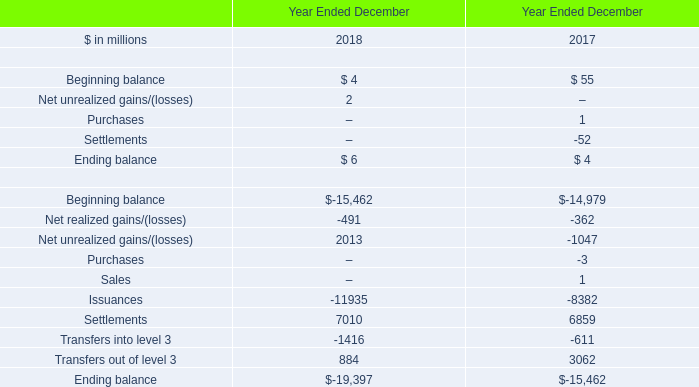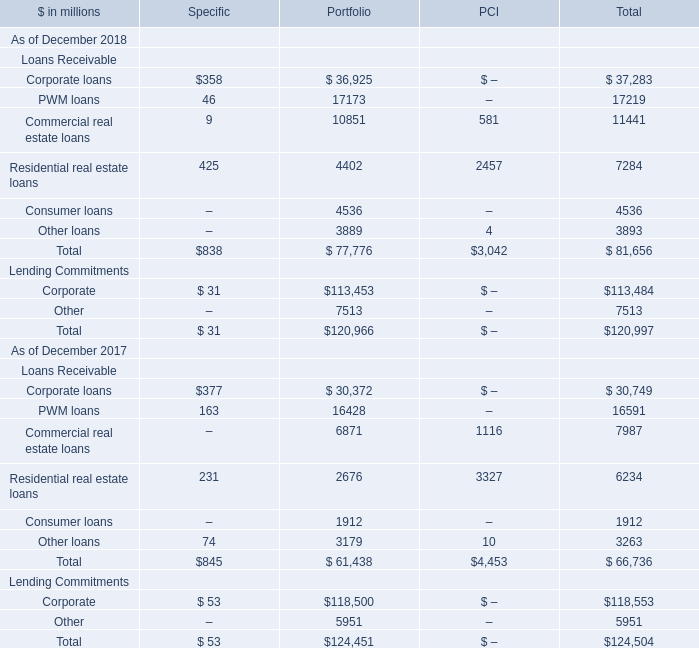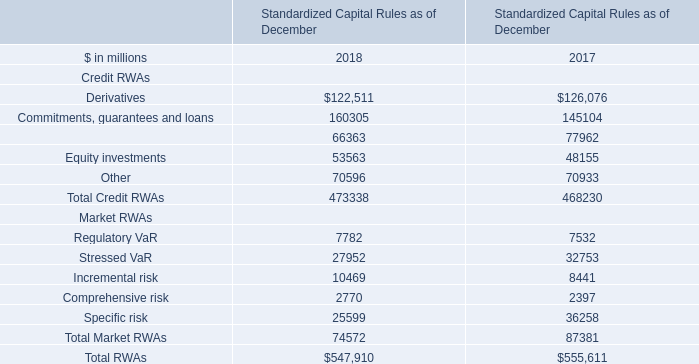What will Corporate loans be like in 2019 if it develops with the same increasing rate as current? (in million) 
Computations: ((1 + ((37283 - 30749) / 30749)) * 37283)
Answer: 45205.44047. 